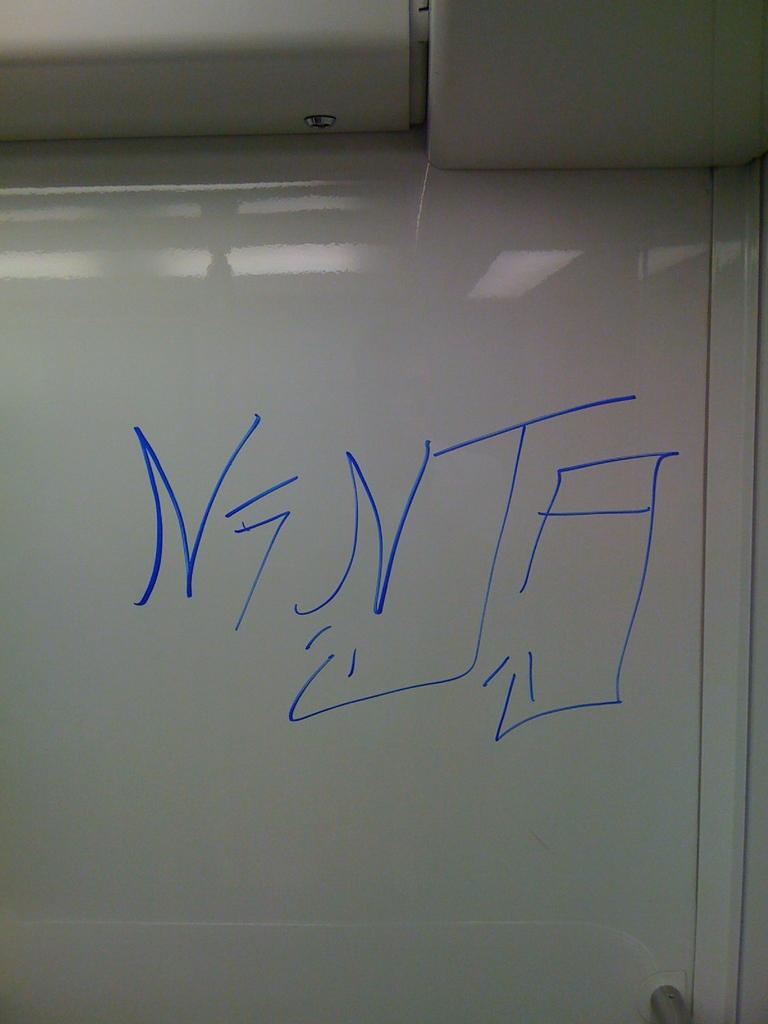<image>
Create a compact narrative representing the image presented. someone drew NINJA on a whiteboard with blue marker 